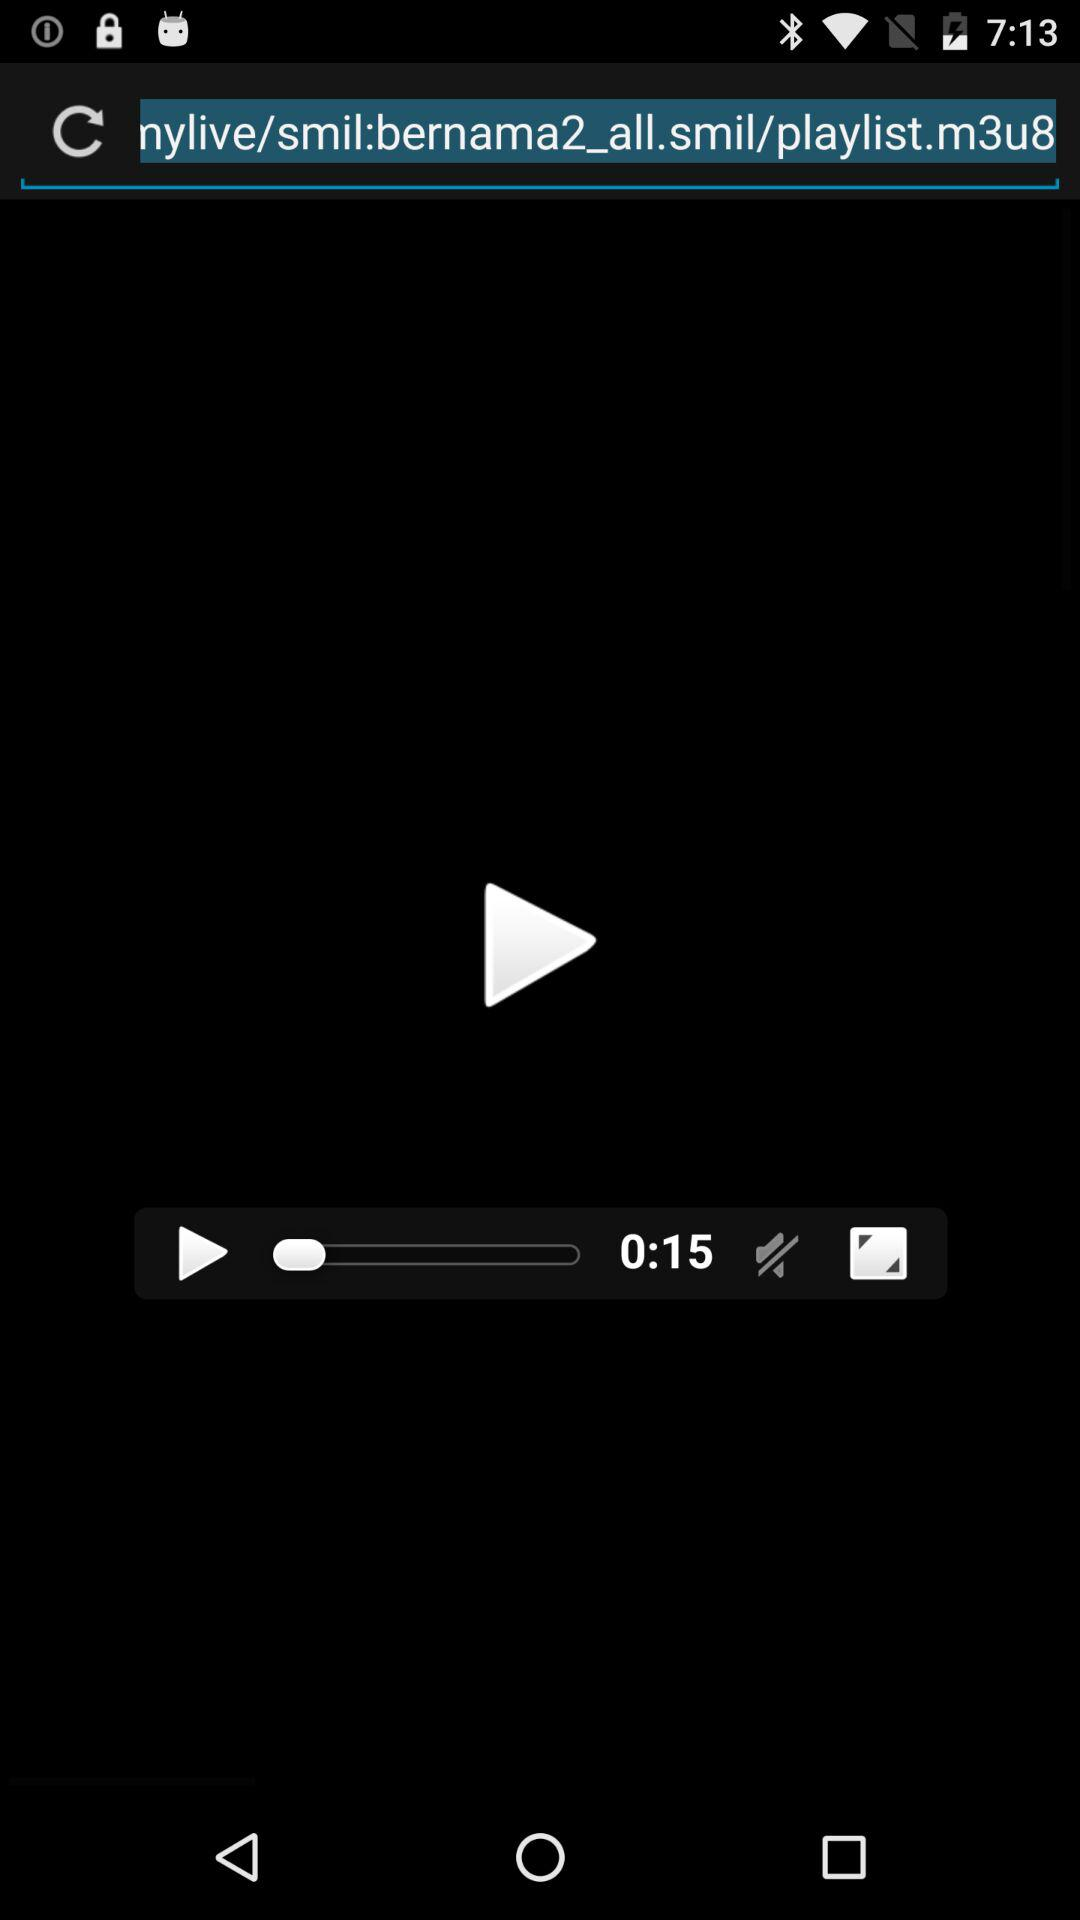How long is the video? The video is 15 seconds long. 